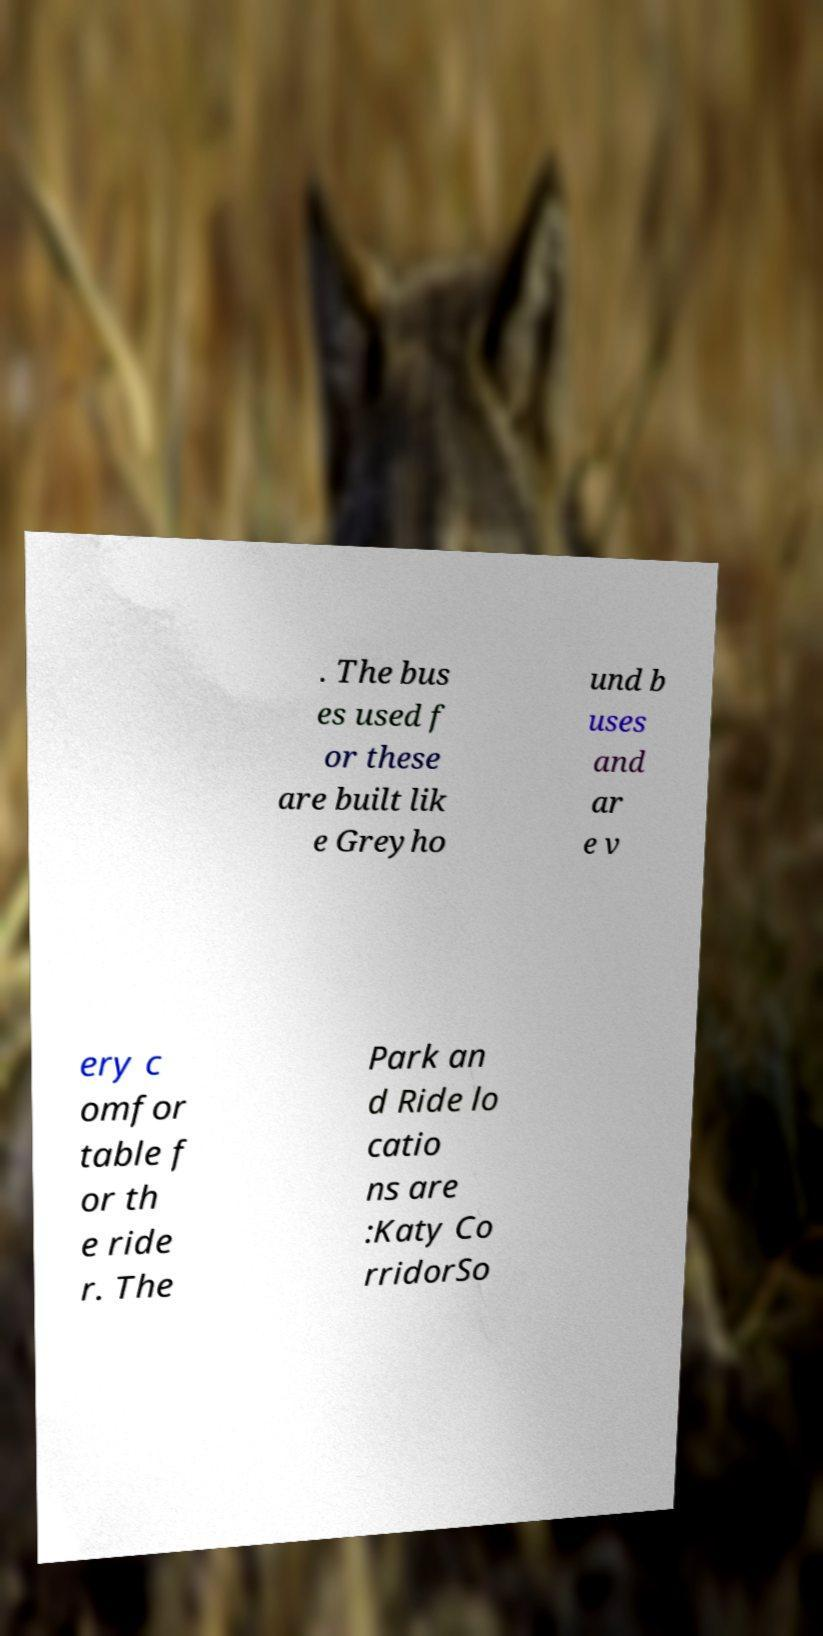Please read and relay the text visible in this image. What does it say? . The bus es used f or these are built lik e Greyho und b uses and ar e v ery c omfor table f or th e ride r. The Park an d Ride lo catio ns are :Katy Co rridorSo 